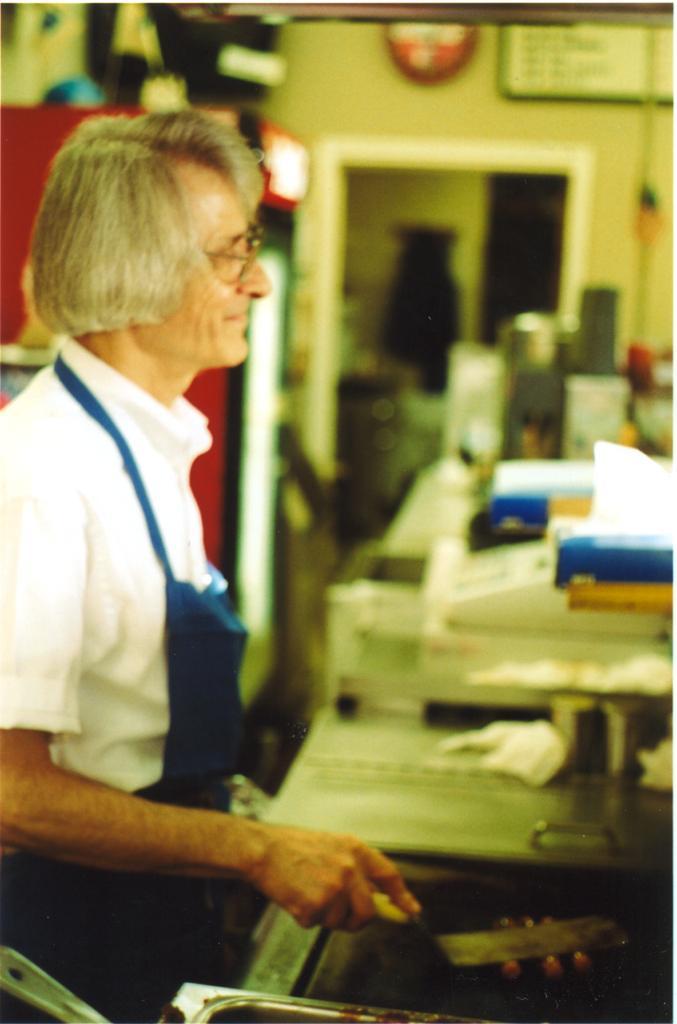Could you give a brief overview of what you see in this image? In this picture I can observe a person on the left side. The person is standing in front of a desk. I can observe few things placed on this desk. In the background there is a wall. 